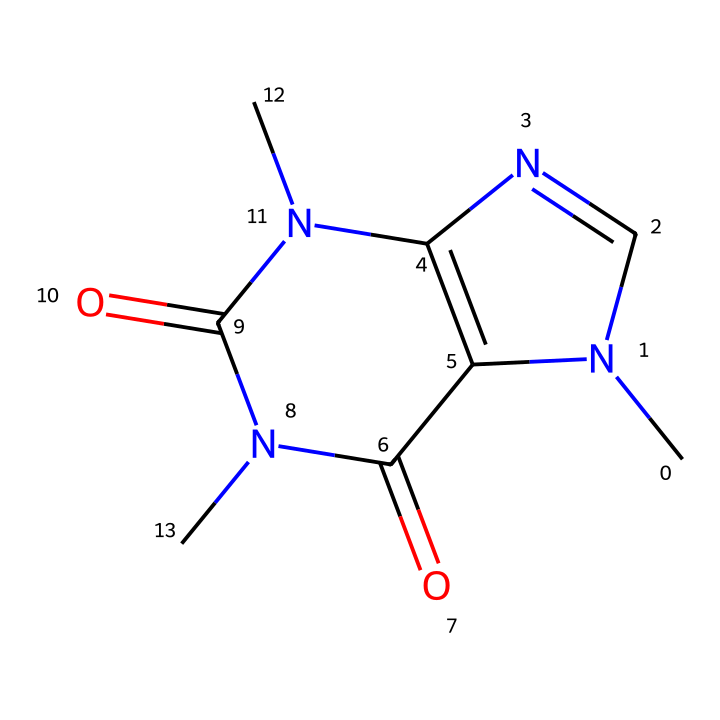What is the molecular formula of caffeine? To find the molecular formula, count the number of carbon (C), hydrogen (H), nitrogen (N), and oxygen (O) atoms depicted in the SMILES representation. The breakdown yields 8 carbon, 10 hydrogen, 4 nitrogen, and 2 oxygen atoms. Therefore, the molecular formula is C8H10N4O2.
Answer: C8H10N4O2 How many nitrogen atoms are in caffeine? Inspect the SMILES representation and identify the nitrogen (N) elements. There are a total of four nitrogen atoms present in the structure.
Answer: 4 Does caffeine contain any double bonds? Analyze the SMILES string for any "=" symbols, which indicate double bonds. There are several occurrences of "=" in the structure, confirming the presence of double bonds.
Answer: Yes What type of compound is caffeine classified as? By examining the structure, caffeine has rings and nitrogen atoms, indicating that it is an alkaloid, which is a class of nitrogen-containing organic compounds.
Answer: alkaloid How many rings are present in caffeine's structure? Looking closely at the chemical structure represented in the SMILES notation, there are two fused rings, which is characteristic of caffeine's molecular architecture.
Answer: 2 Which functional groups are present in caffeine? Analyze the structure for recognizable functional groups such as carbonyl (C=O) or amine (N). Caffeine has both carbonyl and amine groups.
Answer: carbonyl, amine What is the main cultural significance of caffeine? Consider the role of caffeine as a stimulant widely consumed in coffee, tea, and other beverages, indicating its social and cultural importance as an energy-boosting compound.
Answer: stimulant 